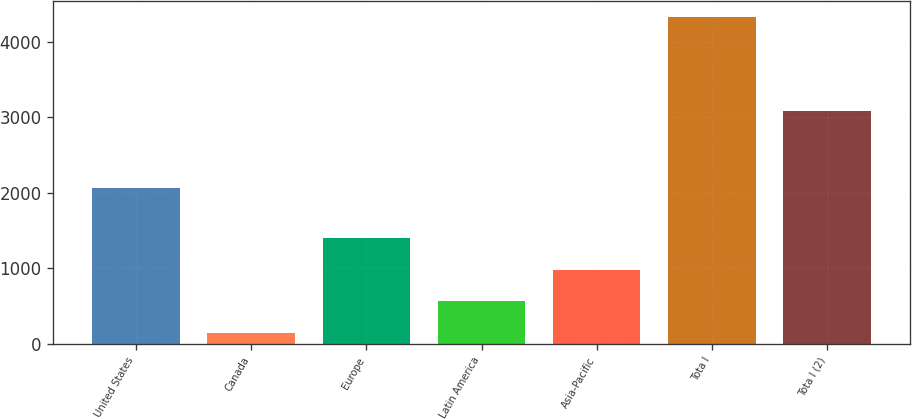<chart> <loc_0><loc_0><loc_500><loc_500><bar_chart><fcel>United States<fcel>Canada<fcel>Europe<fcel>Latin America<fcel>Asia-Pacific<fcel>Tota l<fcel>Tota l (2)<nl><fcel>2066.3<fcel>148.1<fcel>1402.04<fcel>566.08<fcel>984.06<fcel>4327.9<fcel>3088.8<nl></chart> 